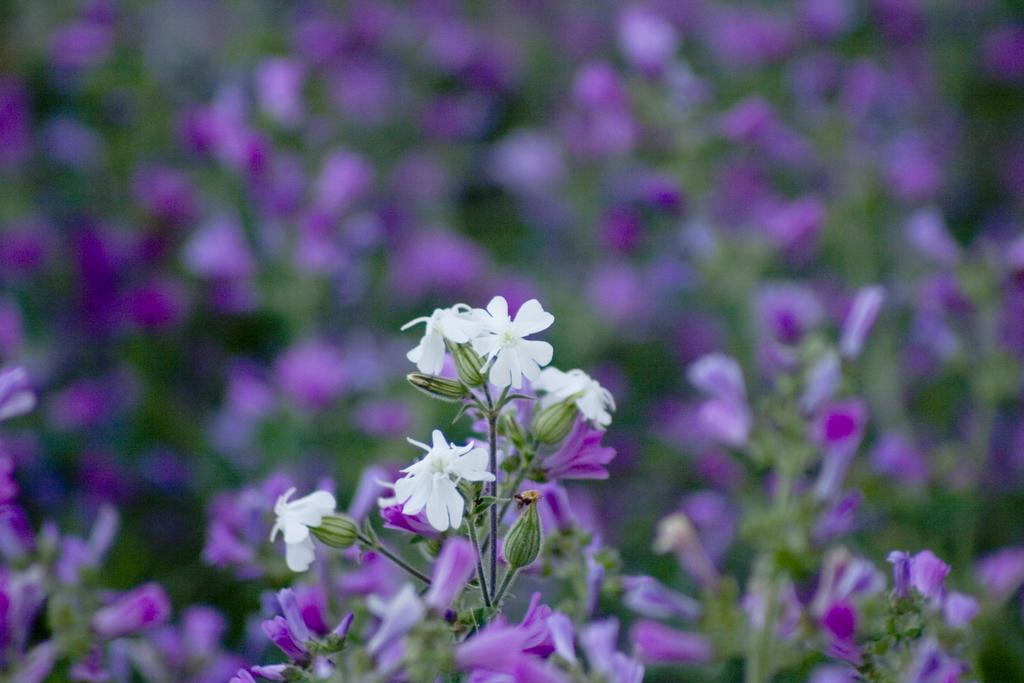What colors are the flowers in the image? The flowers in the image are white and purple. Can you describe the overall quality of the image? The image is slightly blurry in the background. What invention is being demonstrated by the dogs in the image? There are no dogs present in the image, and therefore no invention can be demonstrated. What hope does the image convey? The image does not convey any specific hope or message; it simply depicts flowers. 